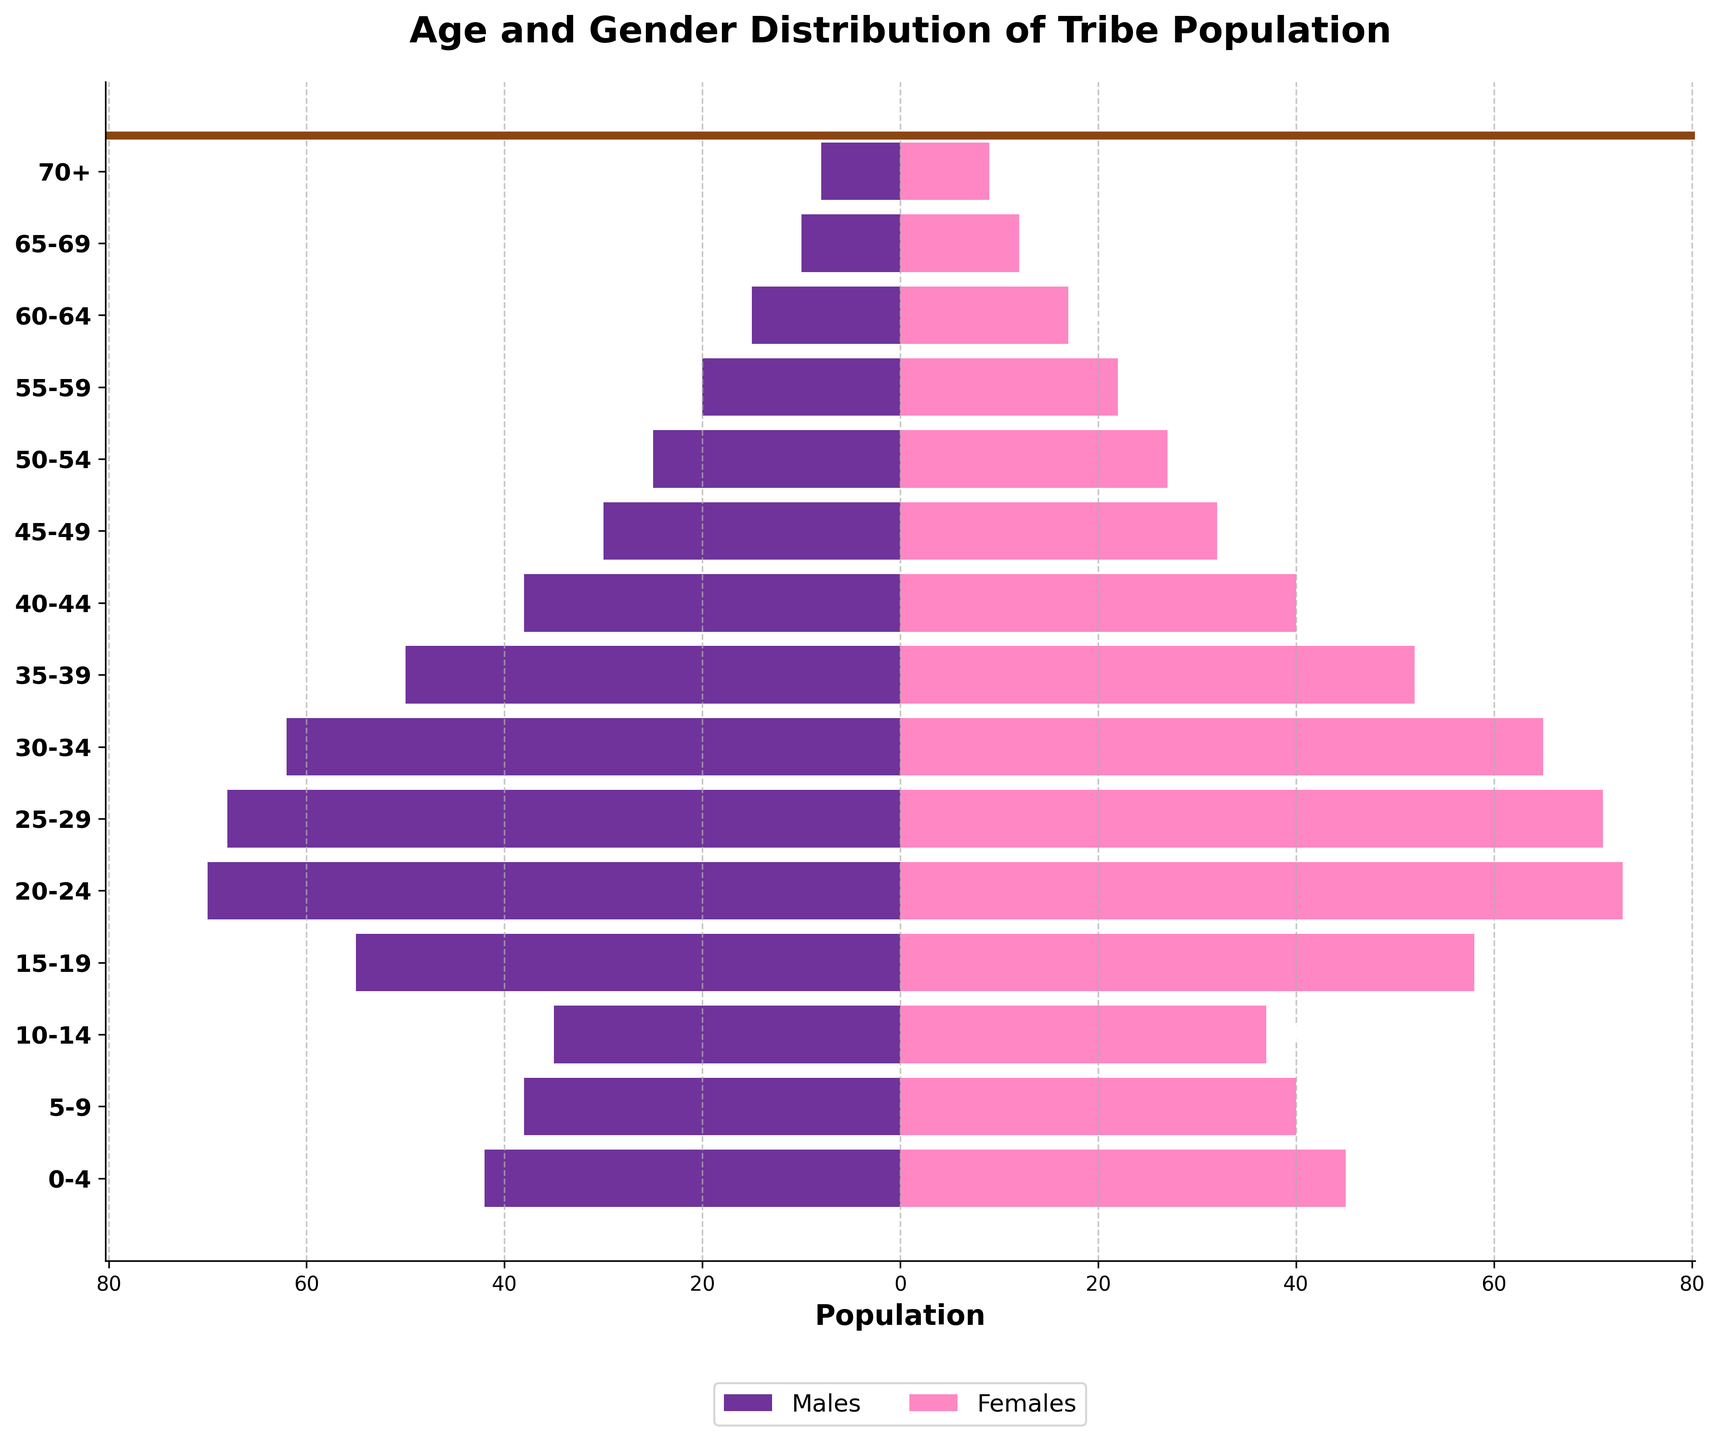What is the title of the figure? The title of the figure is written at the top of the chart in bold.
Answer: Age and Gender Distribution of Tribe Population How many age groups are represented in the figure? By counting the number of distinct age groups listed on the y-axis labels, we conclude there are 15 age groups.
Answer: 15 What color represents males in the plot? The color representing males is visible in the legend; it is a shade of purple.
Answer: Purple In which age group do females outnumber males the most? By comparing the lengths of the bars for each age group, females significantly outnumber males in the 15-19 age group.
Answer: 15-19 What is the total population of the tribe in the 20-24 age group? By summing up the values for males and females in the 20-24 age group: 70 (males) + 73 (females) = 143.
Answer: 143 Which gender has a higher population in the 70+ age group? By comparing the lengths of the bars for the 70+ age group, females have a slightly higher population.
Answer: Females What is the approximate difference in population between females and males in the 25-29 age group? The difference is calculated by subtracting the number of males from the number of females: 71 - 68 = 3.
Answer: 3 Among the age groups 0-4 and 5-9, which has a higher total population? Summing the male and female populations: 0-4 total (42 + 45 = 87) and 5-9 total (38 + 40 = 78). Comparing the totals, 0-4 has a higher population.
Answer: 0-4 In which age group do males have the highest population? By examining the lengths of the bars representing males, the 20-24 age group has the longest bar (70).
Answer: 20-24 